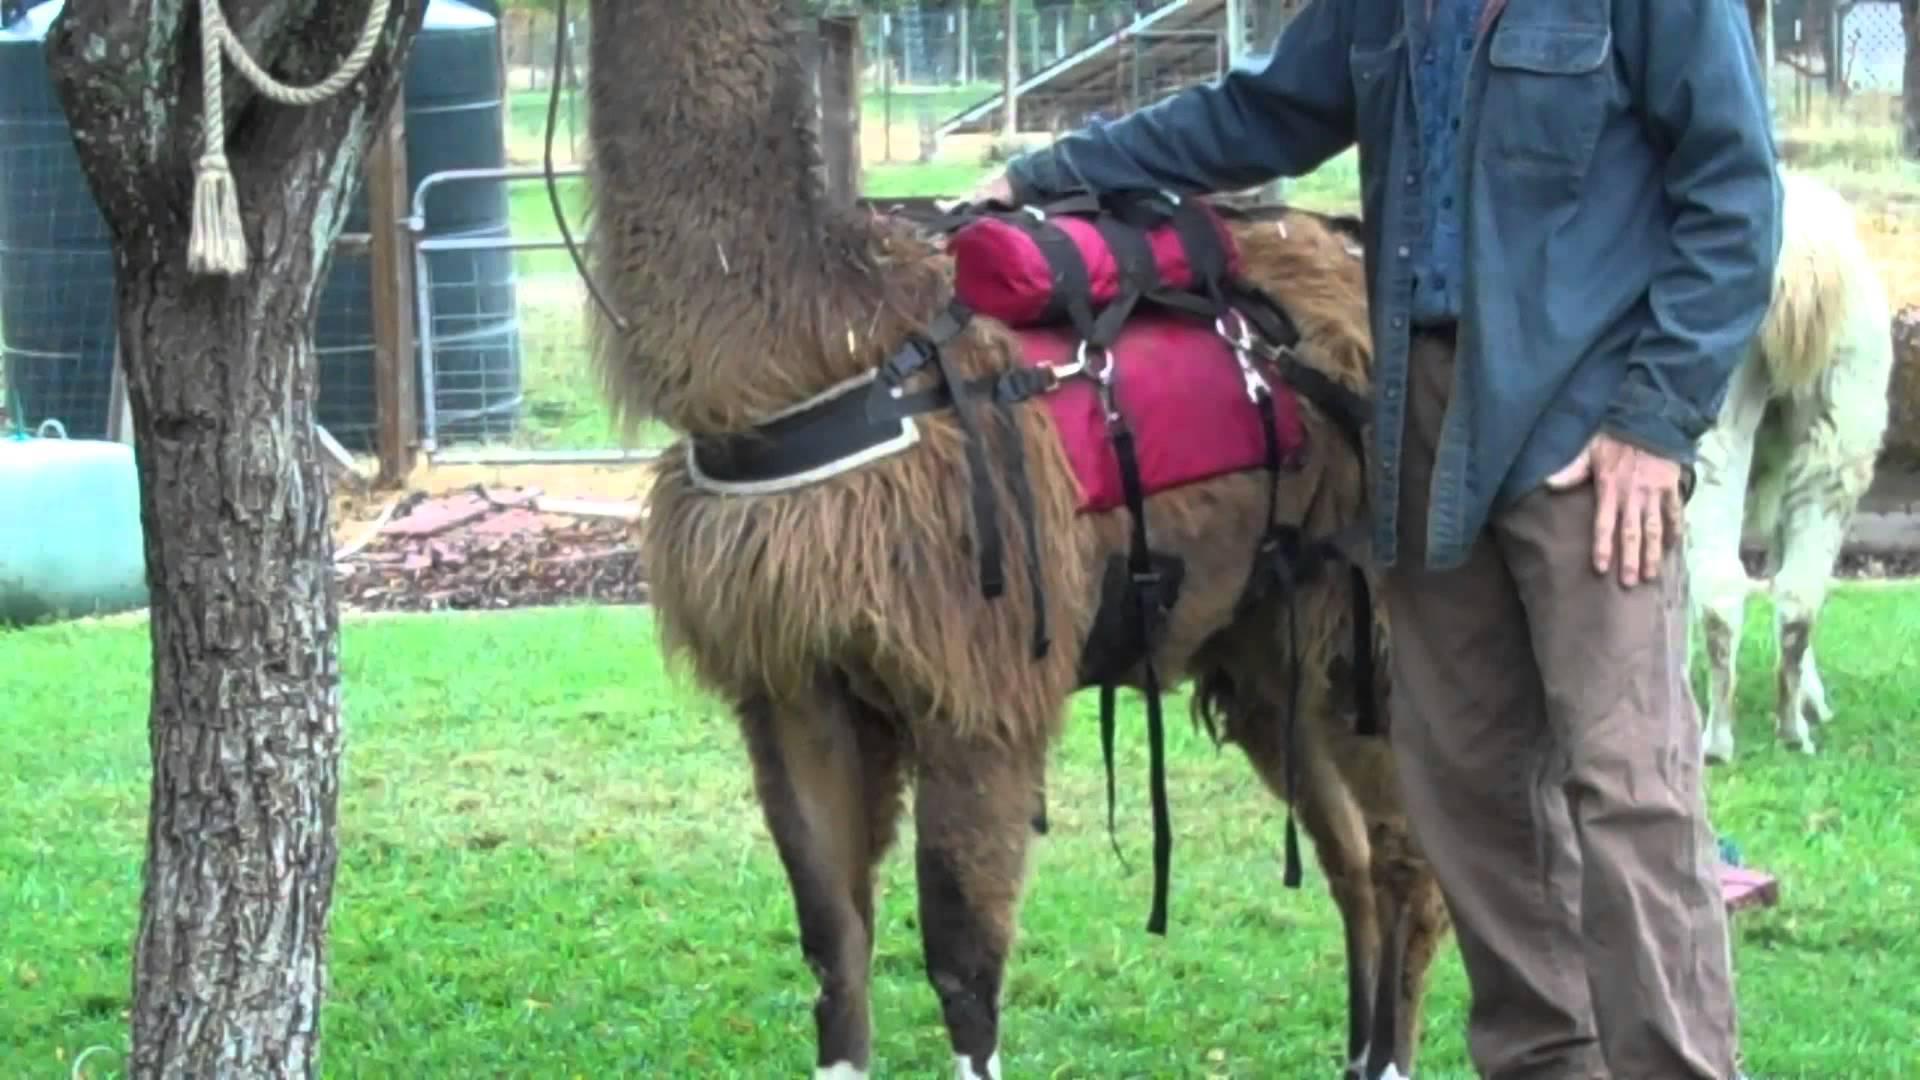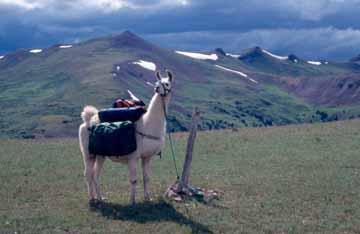The first image is the image on the left, the second image is the image on the right. For the images displayed, is the sentence "In one image, exactly one forward-facing person in sunglasses is standing on an overlook next to the front-end of a llama with its body turned leftward." factually correct? Answer yes or no. No. The first image is the image on the left, the second image is the image on the right. Examine the images to the left and right. Is the description "In one image, a single person is posing to the left of an alpaca." accurate? Answer yes or no. No. 